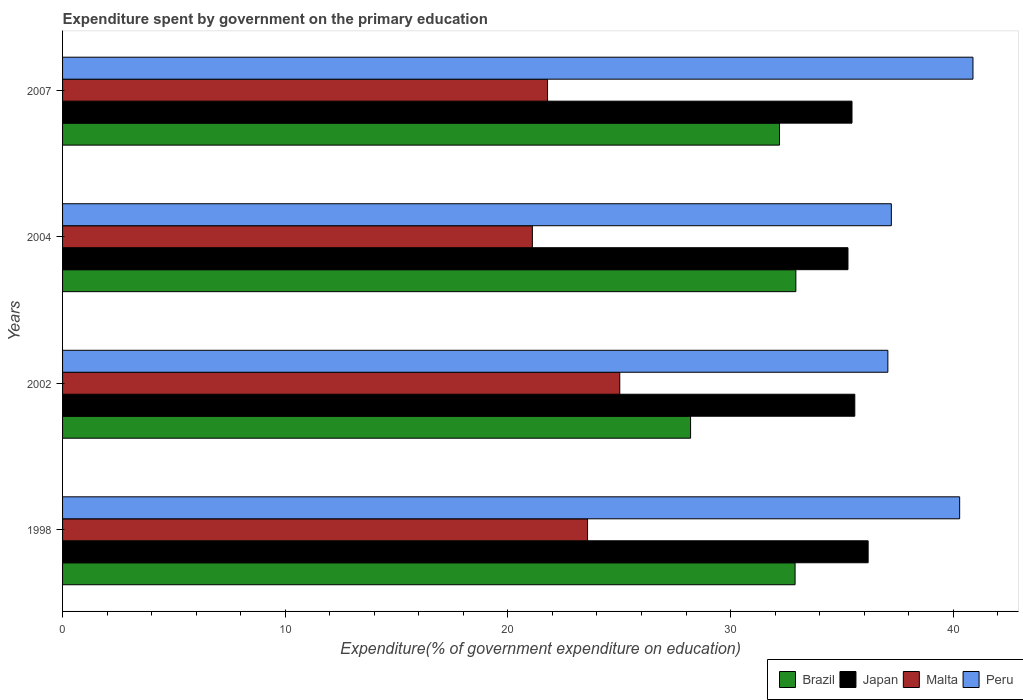How many different coloured bars are there?
Offer a very short reply. 4. How many bars are there on the 2nd tick from the top?
Keep it short and to the point. 4. How many bars are there on the 1st tick from the bottom?
Make the answer very short. 4. In how many cases, is the number of bars for a given year not equal to the number of legend labels?
Offer a terse response. 0. What is the expenditure spent by government on the primary education in Malta in 2002?
Keep it short and to the point. 25.02. Across all years, what is the maximum expenditure spent by government on the primary education in Brazil?
Offer a terse response. 32.93. Across all years, what is the minimum expenditure spent by government on the primary education in Brazil?
Provide a succinct answer. 28.2. What is the total expenditure spent by government on the primary education in Peru in the graph?
Offer a terse response. 155.46. What is the difference between the expenditure spent by government on the primary education in Peru in 2002 and that in 2004?
Keep it short and to the point. -0.16. What is the difference between the expenditure spent by government on the primary education in Brazil in 2004 and the expenditure spent by government on the primary education in Japan in 2002?
Ensure brevity in your answer.  -2.65. What is the average expenditure spent by government on the primary education in Peru per year?
Your answer should be compact. 38.86. In the year 2002, what is the difference between the expenditure spent by government on the primary education in Malta and expenditure spent by government on the primary education in Japan?
Give a very brief answer. -10.56. In how many years, is the expenditure spent by government on the primary education in Malta greater than 36 %?
Keep it short and to the point. 0. What is the ratio of the expenditure spent by government on the primary education in Malta in 1998 to that in 2007?
Provide a short and direct response. 1.08. Is the expenditure spent by government on the primary education in Japan in 1998 less than that in 2002?
Your answer should be very brief. No. Is the difference between the expenditure spent by government on the primary education in Malta in 1998 and 2007 greater than the difference between the expenditure spent by government on the primary education in Japan in 1998 and 2007?
Your answer should be very brief. Yes. What is the difference between the highest and the second highest expenditure spent by government on the primary education in Peru?
Give a very brief answer. 0.6. What is the difference between the highest and the lowest expenditure spent by government on the primary education in Malta?
Provide a short and direct response. 3.92. In how many years, is the expenditure spent by government on the primary education in Brazil greater than the average expenditure spent by government on the primary education in Brazil taken over all years?
Give a very brief answer. 3. Is the sum of the expenditure spent by government on the primary education in Brazil in 1998 and 2002 greater than the maximum expenditure spent by government on the primary education in Peru across all years?
Offer a very short reply. Yes. Is it the case that in every year, the sum of the expenditure spent by government on the primary education in Peru and expenditure spent by government on the primary education in Malta is greater than the sum of expenditure spent by government on the primary education in Brazil and expenditure spent by government on the primary education in Japan?
Your response must be concise. No. What does the 2nd bar from the top in 2007 represents?
Make the answer very short. Malta. What does the 3rd bar from the bottom in 1998 represents?
Your answer should be compact. Malta. Are all the bars in the graph horizontal?
Ensure brevity in your answer.  Yes. Does the graph contain any zero values?
Provide a succinct answer. No. How many legend labels are there?
Your answer should be compact. 4. How are the legend labels stacked?
Offer a very short reply. Horizontal. What is the title of the graph?
Your answer should be compact. Expenditure spent by government on the primary education. What is the label or title of the X-axis?
Offer a terse response. Expenditure(% of government expenditure on education). What is the Expenditure(% of government expenditure on education) of Brazil in 1998?
Offer a terse response. 32.9. What is the Expenditure(% of government expenditure on education) of Japan in 1998?
Provide a short and direct response. 36.18. What is the Expenditure(% of government expenditure on education) of Malta in 1998?
Make the answer very short. 23.58. What is the Expenditure(% of government expenditure on education) of Peru in 1998?
Ensure brevity in your answer.  40.29. What is the Expenditure(% of government expenditure on education) in Brazil in 2002?
Provide a succinct answer. 28.2. What is the Expenditure(% of government expenditure on education) in Japan in 2002?
Your response must be concise. 35.58. What is the Expenditure(% of government expenditure on education) of Malta in 2002?
Ensure brevity in your answer.  25.02. What is the Expenditure(% of government expenditure on education) of Peru in 2002?
Keep it short and to the point. 37.06. What is the Expenditure(% of government expenditure on education) of Brazil in 2004?
Your answer should be compact. 32.93. What is the Expenditure(% of government expenditure on education) in Japan in 2004?
Your answer should be compact. 35.27. What is the Expenditure(% of government expenditure on education) in Malta in 2004?
Your answer should be very brief. 21.1. What is the Expenditure(% of government expenditure on education) in Peru in 2004?
Offer a very short reply. 37.22. What is the Expenditure(% of government expenditure on education) in Brazil in 2007?
Ensure brevity in your answer.  32.2. What is the Expenditure(% of government expenditure on education) in Japan in 2007?
Your response must be concise. 35.45. What is the Expenditure(% of government expenditure on education) in Malta in 2007?
Ensure brevity in your answer.  21.78. What is the Expenditure(% of government expenditure on education) in Peru in 2007?
Give a very brief answer. 40.89. Across all years, what is the maximum Expenditure(% of government expenditure on education) of Brazil?
Provide a short and direct response. 32.93. Across all years, what is the maximum Expenditure(% of government expenditure on education) of Japan?
Keep it short and to the point. 36.18. Across all years, what is the maximum Expenditure(% of government expenditure on education) in Malta?
Offer a terse response. 25.02. Across all years, what is the maximum Expenditure(% of government expenditure on education) in Peru?
Ensure brevity in your answer.  40.89. Across all years, what is the minimum Expenditure(% of government expenditure on education) in Brazil?
Ensure brevity in your answer.  28.2. Across all years, what is the minimum Expenditure(% of government expenditure on education) in Japan?
Offer a very short reply. 35.27. Across all years, what is the minimum Expenditure(% of government expenditure on education) in Malta?
Offer a terse response. 21.1. Across all years, what is the minimum Expenditure(% of government expenditure on education) in Peru?
Keep it short and to the point. 37.06. What is the total Expenditure(% of government expenditure on education) of Brazil in the graph?
Give a very brief answer. 126.23. What is the total Expenditure(% of government expenditure on education) in Japan in the graph?
Make the answer very short. 142.48. What is the total Expenditure(% of government expenditure on education) in Malta in the graph?
Keep it short and to the point. 91.48. What is the total Expenditure(% of government expenditure on education) of Peru in the graph?
Your answer should be compact. 155.46. What is the difference between the Expenditure(% of government expenditure on education) in Brazil in 1998 and that in 2002?
Provide a succinct answer. 4.69. What is the difference between the Expenditure(% of government expenditure on education) in Japan in 1998 and that in 2002?
Keep it short and to the point. 0.6. What is the difference between the Expenditure(% of government expenditure on education) in Malta in 1998 and that in 2002?
Your response must be concise. -1.45. What is the difference between the Expenditure(% of government expenditure on education) in Peru in 1998 and that in 2002?
Your response must be concise. 3.22. What is the difference between the Expenditure(% of government expenditure on education) in Brazil in 1998 and that in 2004?
Offer a very short reply. -0.03. What is the difference between the Expenditure(% of government expenditure on education) in Japan in 1998 and that in 2004?
Provide a succinct answer. 0.91. What is the difference between the Expenditure(% of government expenditure on education) in Malta in 1998 and that in 2004?
Keep it short and to the point. 2.48. What is the difference between the Expenditure(% of government expenditure on education) in Peru in 1998 and that in 2004?
Provide a short and direct response. 3.07. What is the difference between the Expenditure(% of government expenditure on education) in Brazil in 1998 and that in 2007?
Your answer should be compact. 0.7. What is the difference between the Expenditure(% of government expenditure on education) of Japan in 1998 and that in 2007?
Make the answer very short. 0.73. What is the difference between the Expenditure(% of government expenditure on education) in Malta in 1998 and that in 2007?
Ensure brevity in your answer.  1.8. What is the difference between the Expenditure(% of government expenditure on education) in Peru in 1998 and that in 2007?
Offer a very short reply. -0.6. What is the difference between the Expenditure(% of government expenditure on education) in Brazil in 2002 and that in 2004?
Your answer should be compact. -4.73. What is the difference between the Expenditure(% of government expenditure on education) of Japan in 2002 and that in 2004?
Provide a succinct answer. 0.31. What is the difference between the Expenditure(% of government expenditure on education) in Malta in 2002 and that in 2004?
Provide a succinct answer. 3.92. What is the difference between the Expenditure(% of government expenditure on education) in Peru in 2002 and that in 2004?
Your response must be concise. -0.16. What is the difference between the Expenditure(% of government expenditure on education) of Brazil in 2002 and that in 2007?
Your answer should be very brief. -3.99. What is the difference between the Expenditure(% of government expenditure on education) of Japan in 2002 and that in 2007?
Your answer should be compact. 0.13. What is the difference between the Expenditure(% of government expenditure on education) of Malta in 2002 and that in 2007?
Ensure brevity in your answer.  3.24. What is the difference between the Expenditure(% of government expenditure on education) of Peru in 2002 and that in 2007?
Your answer should be compact. -3.82. What is the difference between the Expenditure(% of government expenditure on education) of Brazil in 2004 and that in 2007?
Keep it short and to the point. 0.73. What is the difference between the Expenditure(% of government expenditure on education) of Japan in 2004 and that in 2007?
Ensure brevity in your answer.  -0.18. What is the difference between the Expenditure(% of government expenditure on education) in Malta in 2004 and that in 2007?
Offer a terse response. -0.68. What is the difference between the Expenditure(% of government expenditure on education) of Peru in 2004 and that in 2007?
Offer a very short reply. -3.67. What is the difference between the Expenditure(% of government expenditure on education) in Brazil in 1998 and the Expenditure(% of government expenditure on education) in Japan in 2002?
Your response must be concise. -2.68. What is the difference between the Expenditure(% of government expenditure on education) in Brazil in 1998 and the Expenditure(% of government expenditure on education) in Malta in 2002?
Provide a succinct answer. 7.87. What is the difference between the Expenditure(% of government expenditure on education) in Brazil in 1998 and the Expenditure(% of government expenditure on education) in Peru in 2002?
Offer a terse response. -4.17. What is the difference between the Expenditure(% of government expenditure on education) of Japan in 1998 and the Expenditure(% of government expenditure on education) of Malta in 2002?
Offer a very short reply. 11.15. What is the difference between the Expenditure(% of government expenditure on education) in Japan in 1998 and the Expenditure(% of government expenditure on education) in Peru in 2002?
Provide a succinct answer. -0.89. What is the difference between the Expenditure(% of government expenditure on education) of Malta in 1998 and the Expenditure(% of government expenditure on education) of Peru in 2002?
Provide a short and direct response. -13.49. What is the difference between the Expenditure(% of government expenditure on education) in Brazil in 1998 and the Expenditure(% of government expenditure on education) in Japan in 2004?
Provide a succinct answer. -2.38. What is the difference between the Expenditure(% of government expenditure on education) in Brazil in 1998 and the Expenditure(% of government expenditure on education) in Malta in 2004?
Your response must be concise. 11.8. What is the difference between the Expenditure(% of government expenditure on education) of Brazil in 1998 and the Expenditure(% of government expenditure on education) of Peru in 2004?
Your response must be concise. -4.32. What is the difference between the Expenditure(% of government expenditure on education) of Japan in 1998 and the Expenditure(% of government expenditure on education) of Malta in 2004?
Provide a short and direct response. 15.08. What is the difference between the Expenditure(% of government expenditure on education) in Japan in 1998 and the Expenditure(% of government expenditure on education) in Peru in 2004?
Your answer should be compact. -1.04. What is the difference between the Expenditure(% of government expenditure on education) of Malta in 1998 and the Expenditure(% of government expenditure on education) of Peru in 2004?
Give a very brief answer. -13.64. What is the difference between the Expenditure(% of government expenditure on education) in Brazil in 1998 and the Expenditure(% of government expenditure on education) in Japan in 2007?
Offer a terse response. -2.56. What is the difference between the Expenditure(% of government expenditure on education) of Brazil in 1998 and the Expenditure(% of government expenditure on education) of Malta in 2007?
Your answer should be very brief. 11.12. What is the difference between the Expenditure(% of government expenditure on education) of Brazil in 1998 and the Expenditure(% of government expenditure on education) of Peru in 2007?
Keep it short and to the point. -7.99. What is the difference between the Expenditure(% of government expenditure on education) in Japan in 1998 and the Expenditure(% of government expenditure on education) in Malta in 2007?
Offer a terse response. 14.4. What is the difference between the Expenditure(% of government expenditure on education) in Japan in 1998 and the Expenditure(% of government expenditure on education) in Peru in 2007?
Your response must be concise. -4.71. What is the difference between the Expenditure(% of government expenditure on education) in Malta in 1998 and the Expenditure(% of government expenditure on education) in Peru in 2007?
Give a very brief answer. -17.31. What is the difference between the Expenditure(% of government expenditure on education) of Brazil in 2002 and the Expenditure(% of government expenditure on education) of Japan in 2004?
Your answer should be compact. -7.07. What is the difference between the Expenditure(% of government expenditure on education) in Brazil in 2002 and the Expenditure(% of government expenditure on education) in Malta in 2004?
Your answer should be compact. 7.11. What is the difference between the Expenditure(% of government expenditure on education) of Brazil in 2002 and the Expenditure(% of government expenditure on education) of Peru in 2004?
Make the answer very short. -9.02. What is the difference between the Expenditure(% of government expenditure on education) of Japan in 2002 and the Expenditure(% of government expenditure on education) of Malta in 2004?
Provide a short and direct response. 14.48. What is the difference between the Expenditure(% of government expenditure on education) in Japan in 2002 and the Expenditure(% of government expenditure on education) in Peru in 2004?
Your answer should be very brief. -1.64. What is the difference between the Expenditure(% of government expenditure on education) of Malta in 2002 and the Expenditure(% of government expenditure on education) of Peru in 2004?
Your answer should be very brief. -12.2. What is the difference between the Expenditure(% of government expenditure on education) in Brazil in 2002 and the Expenditure(% of government expenditure on education) in Japan in 2007?
Provide a succinct answer. -7.25. What is the difference between the Expenditure(% of government expenditure on education) in Brazil in 2002 and the Expenditure(% of government expenditure on education) in Malta in 2007?
Ensure brevity in your answer.  6.42. What is the difference between the Expenditure(% of government expenditure on education) of Brazil in 2002 and the Expenditure(% of government expenditure on education) of Peru in 2007?
Make the answer very short. -12.68. What is the difference between the Expenditure(% of government expenditure on education) in Japan in 2002 and the Expenditure(% of government expenditure on education) in Malta in 2007?
Offer a terse response. 13.8. What is the difference between the Expenditure(% of government expenditure on education) of Japan in 2002 and the Expenditure(% of government expenditure on education) of Peru in 2007?
Your answer should be compact. -5.31. What is the difference between the Expenditure(% of government expenditure on education) in Malta in 2002 and the Expenditure(% of government expenditure on education) in Peru in 2007?
Your response must be concise. -15.86. What is the difference between the Expenditure(% of government expenditure on education) in Brazil in 2004 and the Expenditure(% of government expenditure on education) in Japan in 2007?
Give a very brief answer. -2.52. What is the difference between the Expenditure(% of government expenditure on education) in Brazil in 2004 and the Expenditure(% of government expenditure on education) in Malta in 2007?
Keep it short and to the point. 11.15. What is the difference between the Expenditure(% of government expenditure on education) in Brazil in 2004 and the Expenditure(% of government expenditure on education) in Peru in 2007?
Ensure brevity in your answer.  -7.95. What is the difference between the Expenditure(% of government expenditure on education) in Japan in 2004 and the Expenditure(% of government expenditure on education) in Malta in 2007?
Ensure brevity in your answer.  13.49. What is the difference between the Expenditure(% of government expenditure on education) of Japan in 2004 and the Expenditure(% of government expenditure on education) of Peru in 2007?
Offer a terse response. -5.61. What is the difference between the Expenditure(% of government expenditure on education) in Malta in 2004 and the Expenditure(% of government expenditure on education) in Peru in 2007?
Your answer should be very brief. -19.79. What is the average Expenditure(% of government expenditure on education) in Brazil per year?
Make the answer very short. 31.56. What is the average Expenditure(% of government expenditure on education) of Japan per year?
Provide a short and direct response. 35.62. What is the average Expenditure(% of government expenditure on education) of Malta per year?
Offer a very short reply. 22.87. What is the average Expenditure(% of government expenditure on education) in Peru per year?
Keep it short and to the point. 38.86. In the year 1998, what is the difference between the Expenditure(% of government expenditure on education) of Brazil and Expenditure(% of government expenditure on education) of Japan?
Provide a succinct answer. -3.28. In the year 1998, what is the difference between the Expenditure(% of government expenditure on education) of Brazil and Expenditure(% of government expenditure on education) of Malta?
Offer a very short reply. 9.32. In the year 1998, what is the difference between the Expenditure(% of government expenditure on education) in Brazil and Expenditure(% of government expenditure on education) in Peru?
Ensure brevity in your answer.  -7.39. In the year 1998, what is the difference between the Expenditure(% of government expenditure on education) in Japan and Expenditure(% of government expenditure on education) in Malta?
Ensure brevity in your answer.  12.6. In the year 1998, what is the difference between the Expenditure(% of government expenditure on education) in Japan and Expenditure(% of government expenditure on education) in Peru?
Provide a short and direct response. -4.11. In the year 1998, what is the difference between the Expenditure(% of government expenditure on education) in Malta and Expenditure(% of government expenditure on education) in Peru?
Your answer should be compact. -16.71. In the year 2002, what is the difference between the Expenditure(% of government expenditure on education) of Brazil and Expenditure(% of government expenditure on education) of Japan?
Provide a succinct answer. -7.37. In the year 2002, what is the difference between the Expenditure(% of government expenditure on education) of Brazil and Expenditure(% of government expenditure on education) of Malta?
Offer a terse response. 3.18. In the year 2002, what is the difference between the Expenditure(% of government expenditure on education) in Brazil and Expenditure(% of government expenditure on education) in Peru?
Offer a terse response. -8.86. In the year 2002, what is the difference between the Expenditure(% of government expenditure on education) in Japan and Expenditure(% of government expenditure on education) in Malta?
Give a very brief answer. 10.56. In the year 2002, what is the difference between the Expenditure(% of government expenditure on education) in Japan and Expenditure(% of government expenditure on education) in Peru?
Make the answer very short. -1.48. In the year 2002, what is the difference between the Expenditure(% of government expenditure on education) of Malta and Expenditure(% of government expenditure on education) of Peru?
Ensure brevity in your answer.  -12.04. In the year 2004, what is the difference between the Expenditure(% of government expenditure on education) of Brazil and Expenditure(% of government expenditure on education) of Japan?
Provide a short and direct response. -2.34. In the year 2004, what is the difference between the Expenditure(% of government expenditure on education) in Brazil and Expenditure(% of government expenditure on education) in Malta?
Ensure brevity in your answer.  11.83. In the year 2004, what is the difference between the Expenditure(% of government expenditure on education) of Brazil and Expenditure(% of government expenditure on education) of Peru?
Your answer should be very brief. -4.29. In the year 2004, what is the difference between the Expenditure(% of government expenditure on education) of Japan and Expenditure(% of government expenditure on education) of Malta?
Make the answer very short. 14.17. In the year 2004, what is the difference between the Expenditure(% of government expenditure on education) in Japan and Expenditure(% of government expenditure on education) in Peru?
Provide a short and direct response. -1.95. In the year 2004, what is the difference between the Expenditure(% of government expenditure on education) in Malta and Expenditure(% of government expenditure on education) in Peru?
Your response must be concise. -16.12. In the year 2007, what is the difference between the Expenditure(% of government expenditure on education) in Brazil and Expenditure(% of government expenditure on education) in Japan?
Your response must be concise. -3.26. In the year 2007, what is the difference between the Expenditure(% of government expenditure on education) in Brazil and Expenditure(% of government expenditure on education) in Malta?
Ensure brevity in your answer.  10.42. In the year 2007, what is the difference between the Expenditure(% of government expenditure on education) in Brazil and Expenditure(% of government expenditure on education) in Peru?
Provide a short and direct response. -8.69. In the year 2007, what is the difference between the Expenditure(% of government expenditure on education) in Japan and Expenditure(% of government expenditure on education) in Malta?
Your response must be concise. 13.67. In the year 2007, what is the difference between the Expenditure(% of government expenditure on education) in Japan and Expenditure(% of government expenditure on education) in Peru?
Your response must be concise. -5.43. In the year 2007, what is the difference between the Expenditure(% of government expenditure on education) of Malta and Expenditure(% of government expenditure on education) of Peru?
Make the answer very short. -19.11. What is the ratio of the Expenditure(% of government expenditure on education) of Brazil in 1998 to that in 2002?
Make the answer very short. 1.17. What is the ratio of the Expenditure(% of government expenditure on education) of Japan in 1998 to that in 2002?
Your answer should be very brief. 1.02. What is the ratio of the Expenditure(% of government expenditure on education) of Malta in 1998 to that in 2002?
Your answer should be compact. 0.94. What is the ratio of the Expenditure(% of government expenditure on education) in Peru in 1998 to that in 2002?
Provide a succinct answer. 1.09. What is the ratio of the Expenditure(% of government expenditure on education) of Japan in 1998 to that in 2004?
Make the answer very short. 1.03. What is the ratio of the Expenditure(% of government expenditure on education) in Malta in 1998 to that in 2004?
Ensure brevity in your answer.  1.12. What is the ratio of the Expenditure(% of government expenditure on education) of Peru in 1998 to that in 2004?
Ensure brevity in your answer.  1.08. What is the ratio of the Expenditure(% of government expenditure on education) in Brazil in 1998 to that in 2007?
Offer a very short reply. 1.02. What is the ratio of the Expenditure(% of government expenditure on education) in Japan in 1998 to that in 2007?
Your answer should be very brief. 1.02. What is the ratio of the Expenditure(% of government expenditure on education) of Malta in 1998 to that in 2007?
Your response must be concise. 1.08. What is the ratio of the Expenditure(% of government expenditure on education) in Peru in 1998 to that in 2007?
Give a very brief answer. 0.99. What is the ratio of the Expenditure(% of government expenditure on education) in Brazil in 2002 to that in 2004?
Ensure brevity in your answer.  0.86. What is the ratio of the Expenditure(% of government expenditure on education) in Japan in 2002 to that in 2004?
Your answer should be very brief. 1.01. What is the ratio of the Expenditure(% of government expenditure on education) of Malta in 2002 to that in 2004?
Your answer should be very brief. 1.19. What is the ratio of the Expenditure(% of government expenditure on education) in Brazil in 2002 to that in 2007?
Your answer should be very brief. 0.88. What is the ratio of the Expenditure(% of government expenditure on education) of Japan in 2002 to that in 2007?
Make the answer very short. 1. What is the ratio of the Expenditure(% of government expenditure on education) in Malta in 2002 to that in 2007?
Make the answer very short. 1.15. What is the ratio of the Expenditure(% of government expenditure on education) in Peru in 2002 to that in 2007?
Give a very brief answer. 0.91. What is the ratio of the Expenditure(% of government expenditure on education) of Brazil in 2004 to that in 2007?
Your response must be concise. 1.02. What is the ratio of the Expenditure(% of government expenditure on education) in Japan in 2004 to that in 2007?
Give a very brief answer. 0.99. What is the ratio of the Expenditure(% of government expenditure on education) of Malta in 2004 to that in 2007?
Provide a short and direct response. 0.97. What is the ratio of the Expenditure(% of government expenditure on education) in Peru in 2004 to that in 2007?
Offer a terse response. 0.91. What is the difference between the highest and the second highest Expenditure(% of government expenditure on education) in Brazil?
Offer a terse response. 0.03. What is the difference between the highest and the second highest Expenditure(% of government expenditure on education) of Japan?
Your response must be concise. 0.6. What is the difference between the highest and the second highest Expenditure(% of government expenditure on education) in Malta?
Ensure brevity in your answer.  1.45. What is the difference between the highest and the second highest Expenditure(% of government expenditure on education) in Peru?
Make the answer very short. 0.6. What is the difference between the highest and the lowest Expenditure(% of government expenditure on education) in Brazil?
Make the answer very short. 4.73. What is the difference between the highest and the lowest Expenditure(% of government expenditure on education) of Japan?
Your response must be concise. 0.91. What is the difference between the highest and the lowest Expenditure(% of government expenditure on education) in Malta?
Your response must be concise. 3.92. What is the difference between the highest and the lowest Expenditure(% of government expenditure on education) of Peru?
Your answer should be very brief. 3.82. 